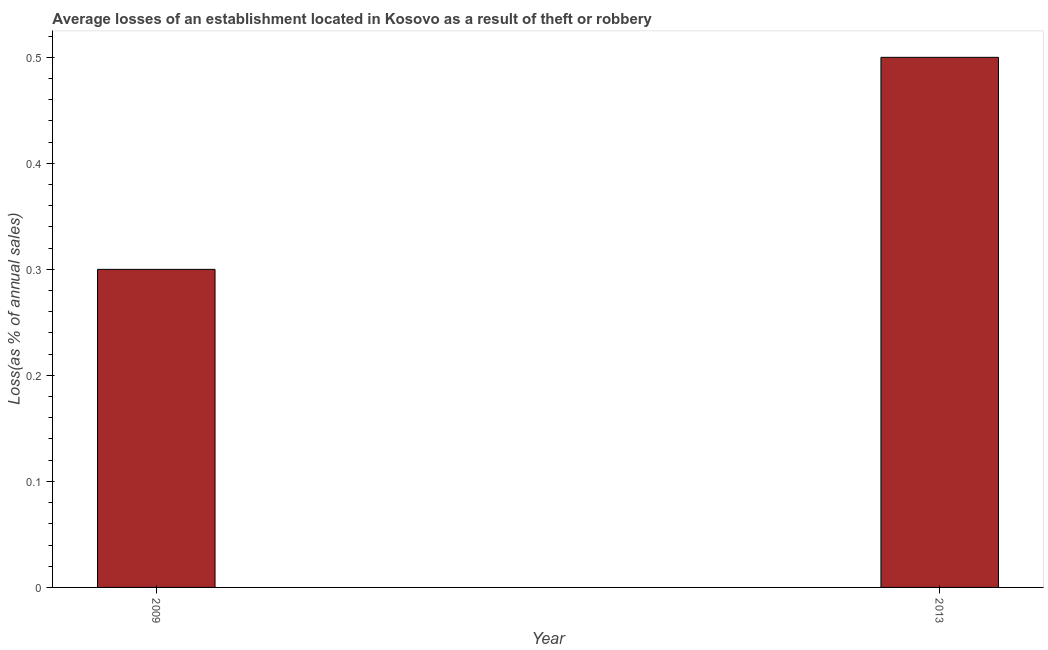What is the title of the graph?
Give a very brief answer. Average losses of an establishment located in Kosovo as a result of theft or robbery. What is the label or title of the Y-axis?
Provide a short and direct response. Loss(as % of annual sales). Across all years, what is the maximum losses due to theft?
Your response must be concise. 0.5. In which year was the losses due to theft maximum?
Offer a very short reply. 2013. In which year was the losses due to theft minimum?
Keep it short and to the point. 2009. What is the sum of the losses due to theft?
Make the answer very short. 0.8. What is the average losses due to theft per year?
Provide a succinct answer. 0.4. In how many years, is the losses due to theft greater than 0.24 %?
Offer a very short reply. 2. What is the Loss(as % of annual sales) in 2009?
Ensure brevity in your answer.  0.3. What is the ratio of the Loss(as % of annual sales) in 2009 to that in 2013?
Your answer should be compact. 0.6. 